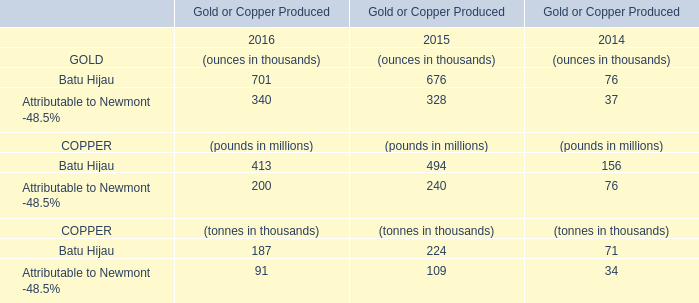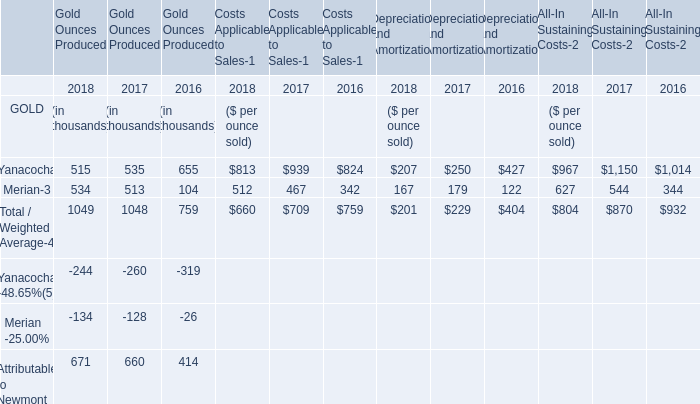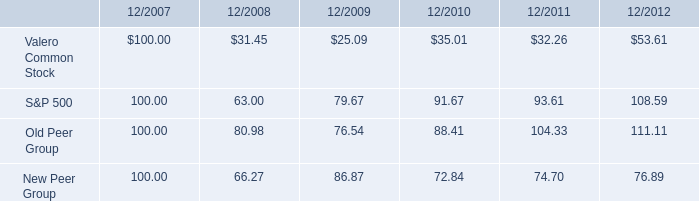Which year is Gold Ounces Produced by Yanacocha the least? 
Answer: 2018. 